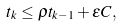<formula> <loc_0><loc_0><loc_500><loc_500>t _ { k } \leq \rho t _ { k - 1 } + \varepsilon C ,</formula> 